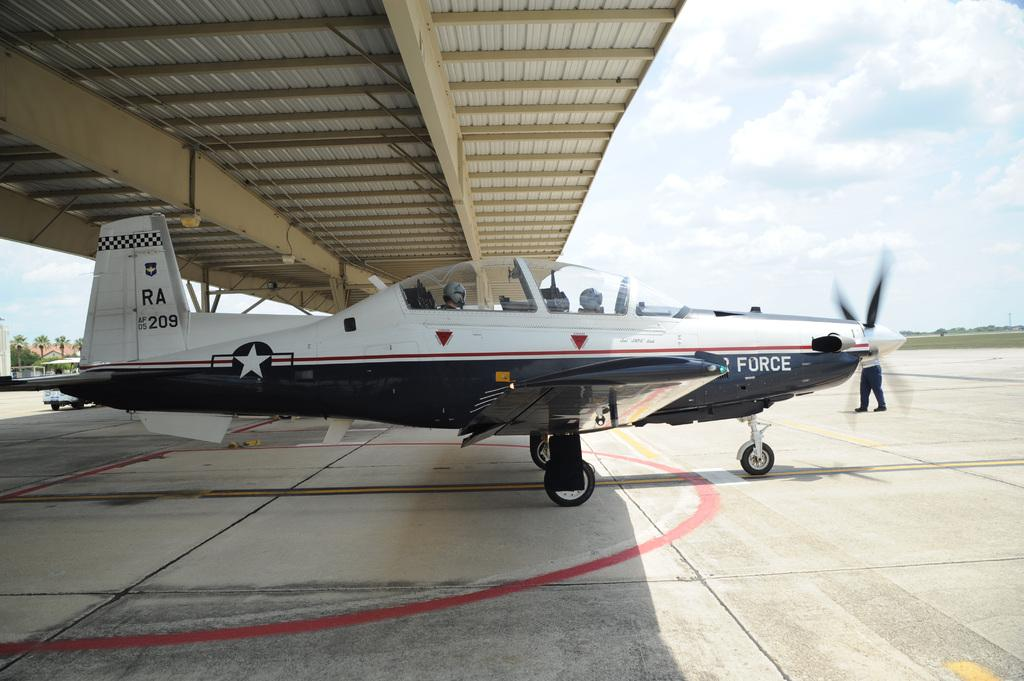<image>
Summarize the visual content of the image. An Air Force plane is under an awing on a runway. 